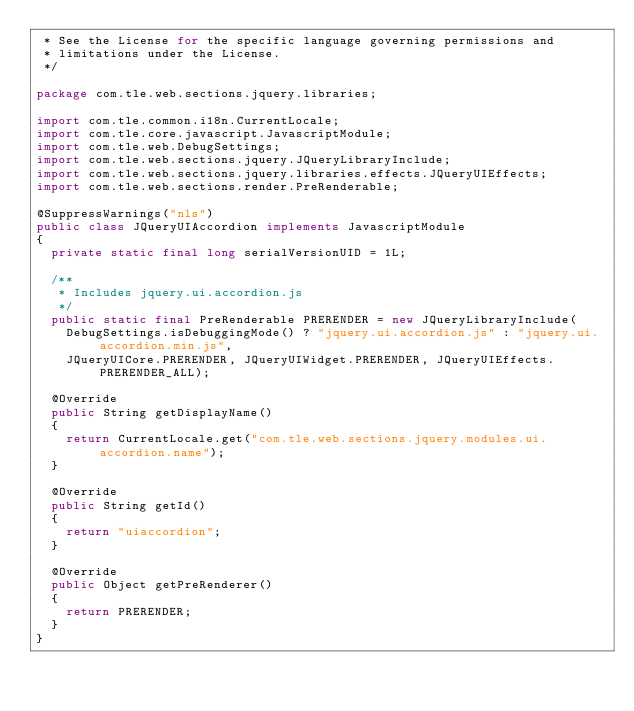Convert code to text. <code><loc_0><loc_0><loc_500><loc_500><_Java_> * See the License for the specific language governing permissions and
 * limitations under the License.
 */

package com.tle.web.sections.jquery.libraries;

import com.tle.common.i18n.CurrentLocale;
import com.tle.core.javascript.JavascriptModule;
import com.tle.web.DebugSettings;
import com.tle.web.sections.jquery.JQueryLibraryInclude;
import com.tle.web.sections.jquery.libraries.effects.JQueryUIEffects;
import com.tle.web.sections.render.PreRenderable;

@SuppressWarnings("nls")
public class JQueryUIAccordion implements JavascriptModule
{
	private static final long serialVersionUID = 1L;

	/**
	 * Includes jquery.ui.accordion.js
	 */
	public static final PreRenderable PRERENDER = new JQueryLibraryInclude(
		DebugSettings.isDebuggingMode() ? "jquery.ui.accordion.js" : "jquery.ui.accordion.min.js",
		JQueryUICore.PRERENDER, JQueryUIWidget.PRERENDER, JQueryUIEffects.PRERENDER_ALL);

	@Override
	public String getDisplayName()
	{
		return CurrentLocale.get("com.tle.web.sections.jquery.modules.ui.accordion.name");
	}

	@Override
	public String getId()
	{
		return "uiaccordion";
	}

	@Override
	public Object getPreRenderer()
	{
		return PRERENDER;
	}
}
</code> 